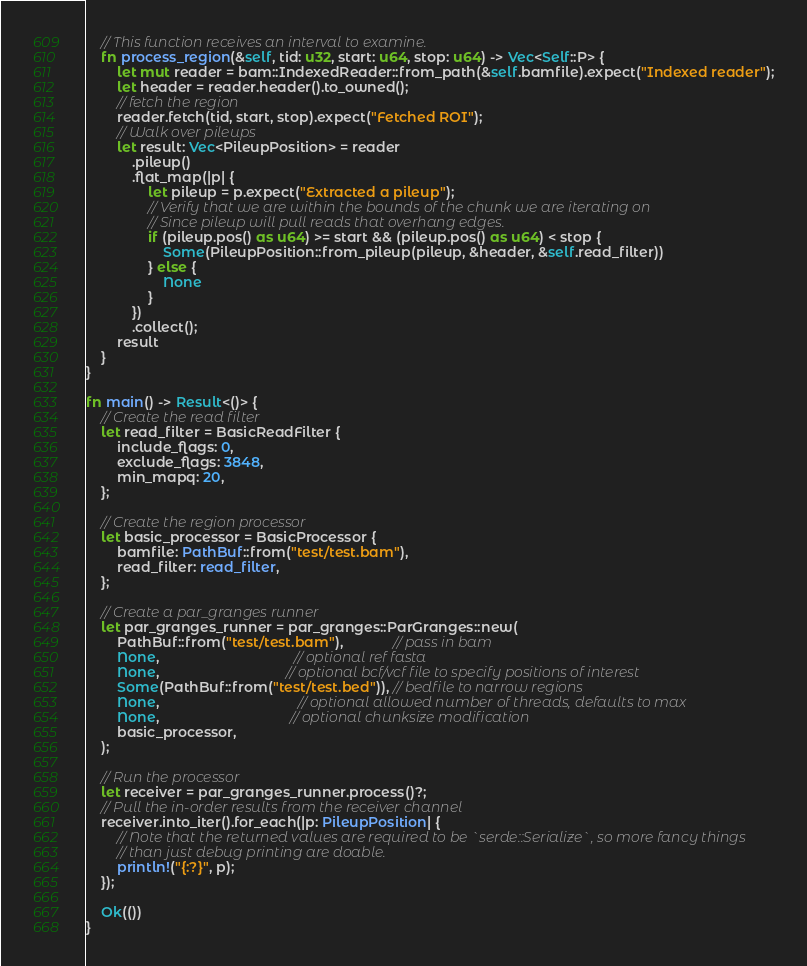Convert code to text. <code><loc_0><loc_0><loc_500><loc_500><_Rust_>
    // This function receives an interval to examine.
    fn process_region(&self, tid: u32, start: u64, stop: u64) -> Vec<Self::P> {
        let mut reader = bam::IndexedReader::from_path(&self.bamfile).expect("Indexed reader");
        let header = reader.header().to_owned();
        // fetch the region
        reader.fetch(tid, start, stop).expect("Fetched ROI");
        // Walk over pileups
        let result: Vec<PileupPosition> = reader
            .pileup()
            .flat_map(|p| {
                let pileup = p.expect("Extracted a pileup");
                // Verify that we are within the bounds of the chunk we are iterating on
                // Since pileup will pull reads that overhang edges.
                if (pileup.pos() as u64) >= start && (pileup.pos() as u64) < stop {
                    Some(PileupPosition::from_pileup(pileup, &header, &self.read_filter))
                } else {
                    None
                }
            })
            .collect();
        result
    }
}

fn main() -> Result<()> {
    // Create the read filter
    let read_filter = BasicReadFilter {
        include_flags: 0,
        exclude_flags: 3848,
        min_mapq: 20,
    };

    // Create the region processor
    let basic_processor = BasicProcessor {
        bamfile: PathBuf::from("test/test.bam"),
        read_filter: read_filter,
    };

    // Create a par_granges runner
    let par_granges_runner = par_granges::ParGranges::new(
        PathBuf::from("test/test.bam"),             // pass in bam
        None,                                   // optional ref fasta
        None,                                 // optional bcf/vcf file to specify positions of interest
        Some(PathBuf::from("test/test.bed")), // bedfile to narrow regions
        None,                                    // optional allowed number of threads, defaults to max
        None,                                  // optional chunksize modification
        basic_processor,
    );

    // Run the processor
    let receiver = par_granges_runner.process()?;
    // Pull the in-order results from the receiver channel
    receiver.into_iter().for_each(|p: PileupPosition| {
        // Note that the returned values are required to be `serde::Serialize`, so more fancy things
        // than just debug printing are doable.
        println!("{:?}", p);
    });

    Ok(())
}
</code> 